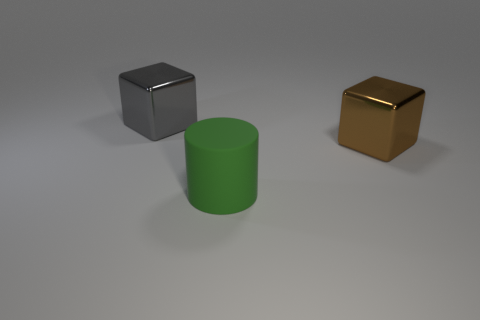There is a block that is right of the shiny block that is to the left of the big shiny block to the right of the green matte thing; how big is it?
Your answer should be compact. Large. What number of cubes are yellow matte objects or matte objects?
Offer a very short reply. 0. There is a big block left of the cube in front of the large gray metal block; what number of large cubes are in front of it?
Ensure brevity in your answer.  1. Are there any other things that have the same material as the cylinder?
Offer a very short reply. No. What color is the cube that is on the right side of the gray object?
Give a very brief answer. Brown. Do the brown thing and the cylinder to the left of the large brown metal cube have the same material?
Give a very brief answer. No. What material is the gray block?
Your answer should be compact. Metal. The large gray thing that is made of the same material as the brown object is what shape?
Provide a short and direct response. Cube. What number of other objects are the same shape as the large brown shiny thing?
Your response must be concise. 1. There is a large brown cube; what number of large blocks are to the left of it?
Offer a terse response. 1. 